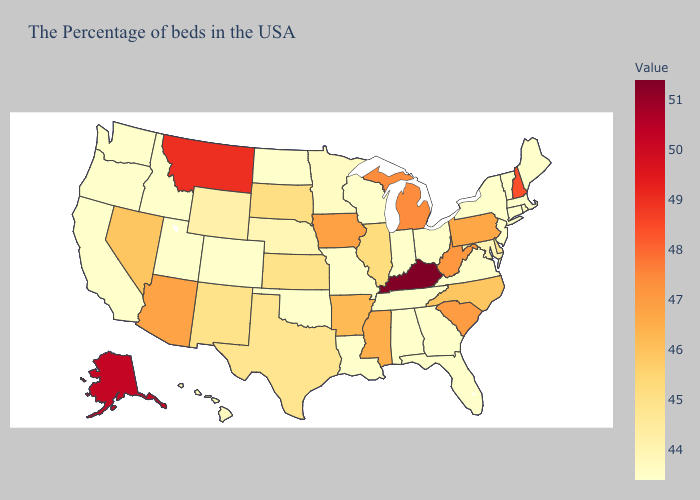Which states hav the highest value in the South?
Keep it brief. Kentucky. Which states hav the highest value in the South?
Quick response, please. Kentucky. Which states have the lowest value in the USA?
Answer briefly. Maine, Massachusetts, Vermont, Connecticut, New York, New Jersey, Virginia, Ohio, Florida, Georgia, Indiana, Alabama, Tennessee, Wisconsin, Louisiana, Missouri, Oklahoma, North Dakota, Colorado, Utah, Idaho, California, Washington, Oregon. Among the states that border Indiana , which have the highest value?
Answer briefly. Kentucky. Among the states that border Nebraska , does Kansas have the highest value?
Be succinct. No. Does New York have the lowest value in the USA?
Concise answer only. Yes. Does Minnesota have the lowest value in the USA?
Answer briefly. No. 